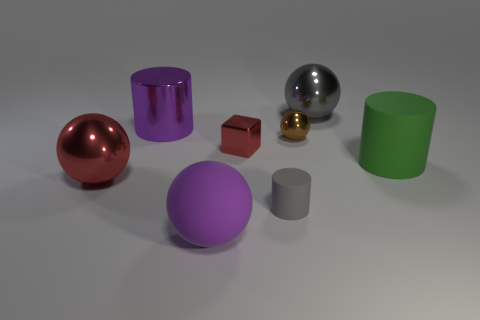There is a green object that is to the right of the large purple matte sphere; what material is it?
Keep it short and to the point. Rubber. Is the size of the green rubber cylinder the same as the gray thing that is in front of the cube?
Make the answer very short. No. The large purple object in front of the tiny block on the right side of the big sphere that is to the left of the rubber sphere is what shape?
Give a very brief answer. Sphere. Are there fewer big things than big balls?
Your answer should be very brief. No. Are there any cylinders on the right side of the brown metallic object?
Your answer should be compact. Yes. There is a large metallic thing that is both behind the tiny metallic block and to the left of the small block; what is its shape?
Make the answer very short. Cylinder. Are there any other brown things that have the same shape as the tiny rubber object?
Provide a succinct answer. No. There is a rubber cylinder that is to the right of the large gray metal thing; is its size the same as the red shiny thing right of the purple metal cylinder?
Your answer should be very brief. No. Are there more large red cylinders than tiny gray things?
Offer a very short reply. No. What number of big purple things have the same material as the big green cylinder?
Your response must be concise. 1. 